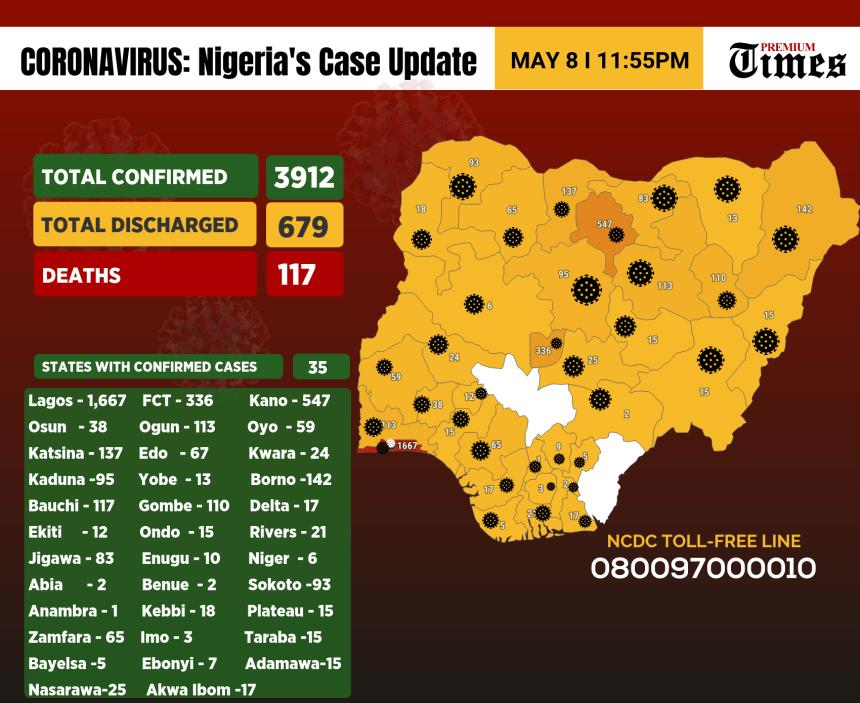Outline some significant characteristics in this image. As of May 8, Lagos state in Nigeria has reported the highest number of confirmed COVID-19 cases, according to official statistics. The state of Kano in Nigeria has reported the second highest number of confirmed COVID-19 cases as of May 8, according to reports. As of May 8th, there have been 142 confirmed cases of COVID-19 reported in Borno state, Nigeria. As of May 8, the number of confirmed Covid-19 positive cases in Enugu State, Nigeria, is 10. As of May 8, Anambra state in Nigeria has reported the lowest number of confirmed COVID-19 cases among all the states in the country. 